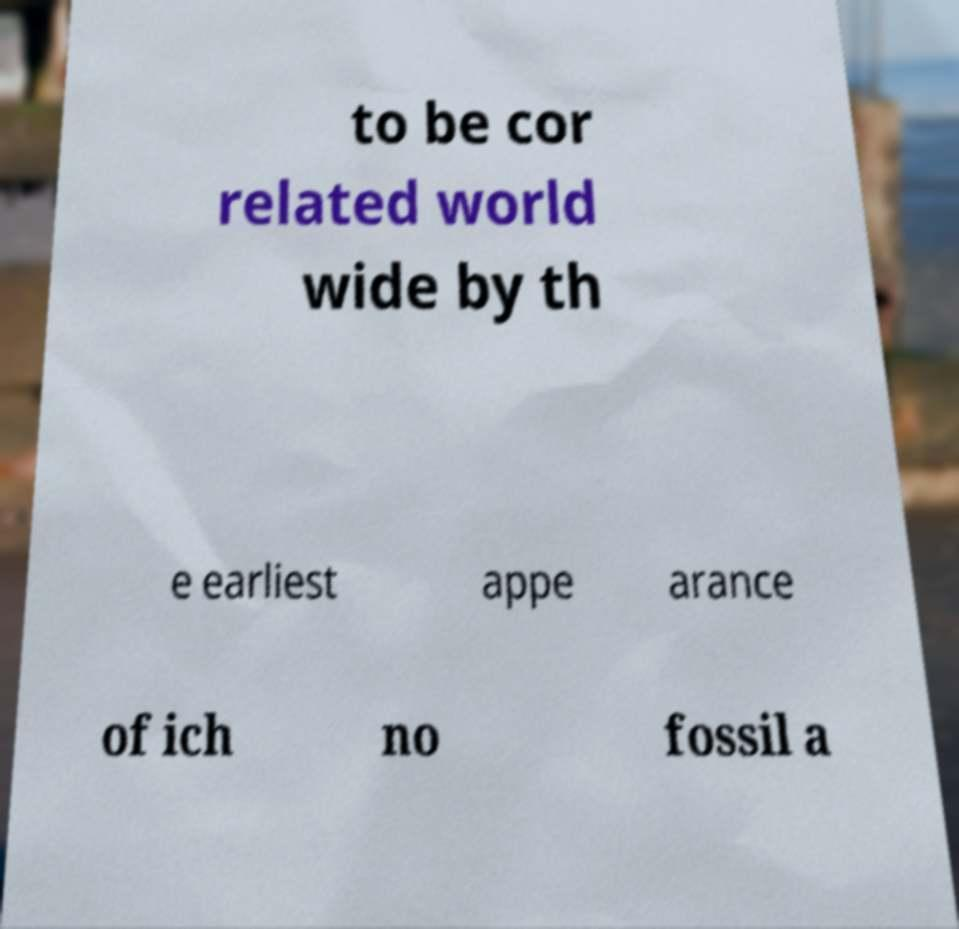I need the written content from this picture converted into text. Can you do that? to be cor related world wide by th e earliest appe arance of ich no fossil a 